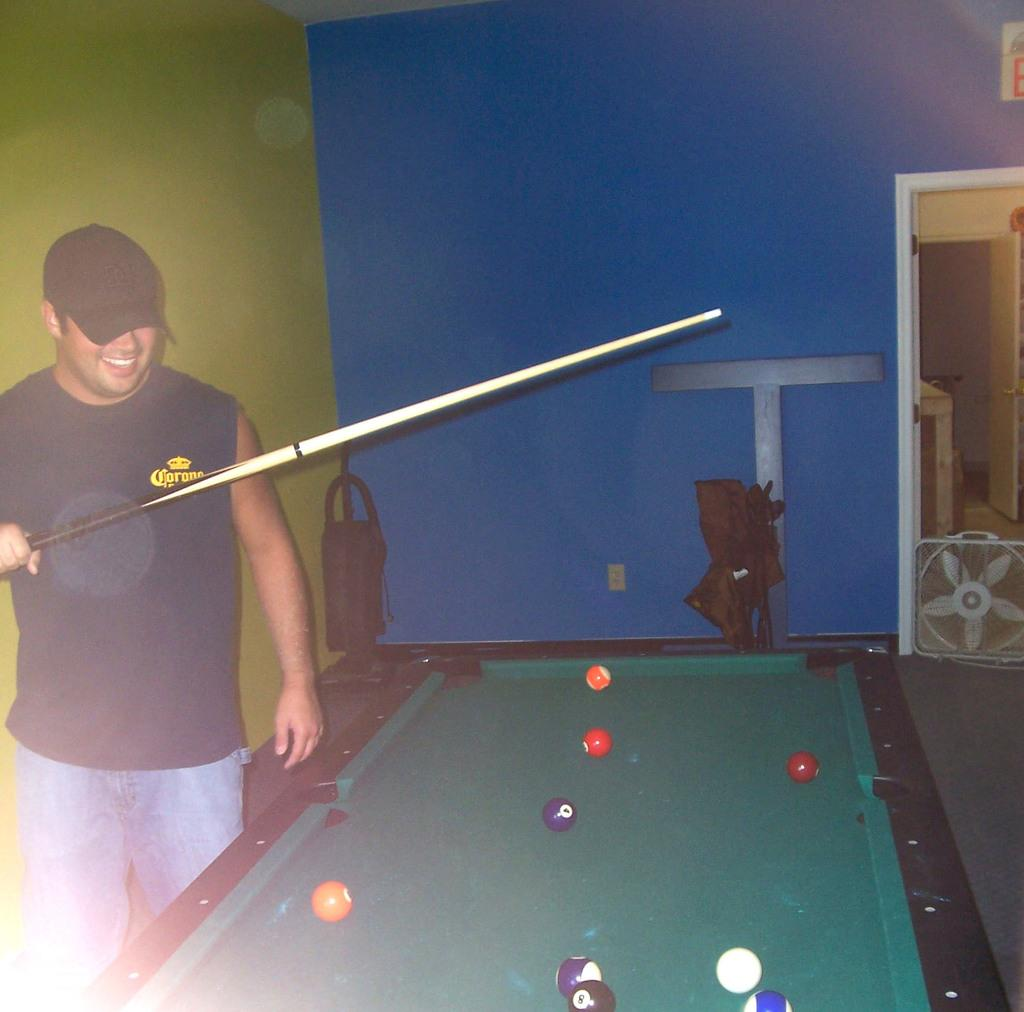Where is the setting of the image? The image is inside a room. Who is present in the image? There is a man in the image. What is the man holding in the image? The man is holding a stick. What can be seen near the man in the image? The man is beside a soccer table. What colors are present on the wall behind the man? The background of the man is a wall with yellow and blue colors. What type of drink is the man consuming in the image? There is no drink present in the image; the man is holding a stick. What kind of fuel is being used by the man in the image? There is no fuel present in the image; the man is holding a stick and standing beside a soccer table. 